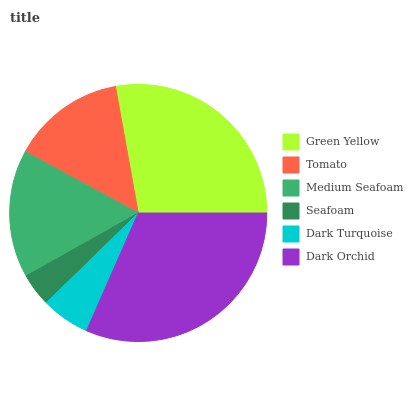Is Seafoam the minimum?
Answer yes or no. Yes. Is Dark Orchid the maximum?
Answer yes or no. Yes. Is Tomato the minimum?
Answer yes or no. No. Is Tomato the maximum?
Answer yes or no. No. Is Green Yellow greater than Tomato?
Answer yes or no. Yes. Is Tomato less than Green Yellow?
Answer yes or no. Yes. Is Tomato greater than Green Yellow?
Answer yes or no. No. Is Green Yellow less than Tomato?
Answer yes or no. No. Is Medium Seafoam the high median?
Answer yes or no. Yes. Is Tomato the low median?
Answer yes or no. Yes. Is Dark Orchid the high median?
Answer yes or no. No. Is Green Yellow the low median?
Answer yes or no. No. 